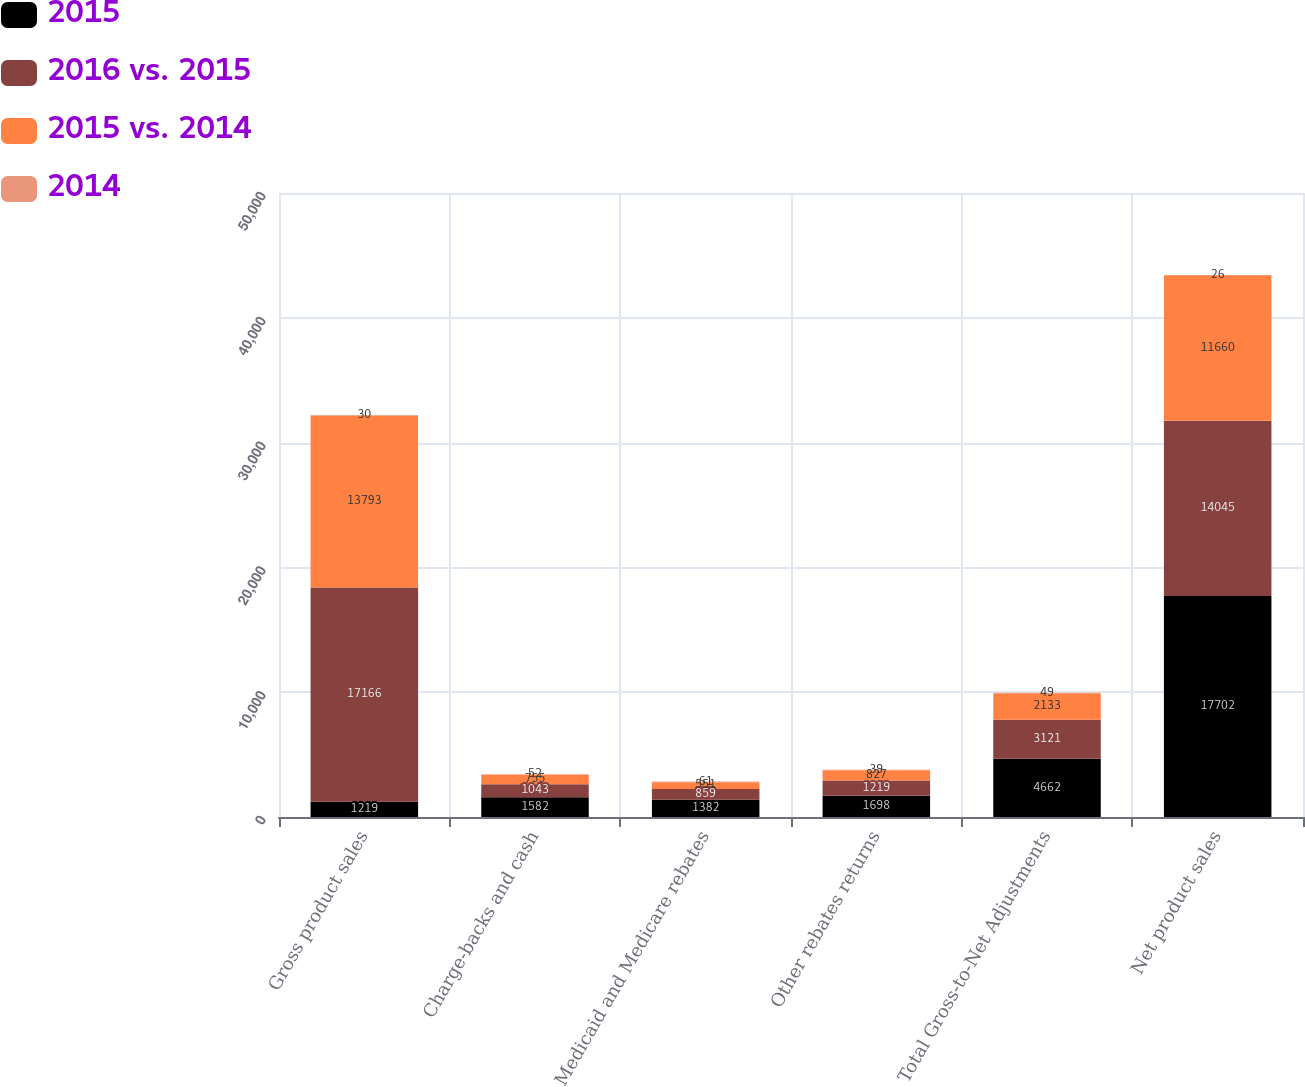<chart> <loc_0><loc_0><loc_500><loc_500><stacked_bar_chart><ecel><fcel>Gross product sales<fcel>Charge-backs and cash<fcel>Medicaid and Medicare rebates<fcel>Other rebates returns<fcel>Total Gross-to-Net Adjustments<fcel>Net product sales<nl><fcel>2015<fcel>1219<fcel>1582<fcel>1382<fcel>1698<fcel>4662<fcel>17702<nl><fcel>2016 vs. 2015<fcel>17166<fcel>1043<fcel>859<fcel>1219<fcel>3121<fcel>14045<nl><fcel>2015 vs. 2014<fcel>13793<fcel>755<fcel>551<fcel>827<fcel>2133<fcel>11660<nl><fcel>2014<fcel>30<fcel>52<fcel>61<fcel>39<fcel>49<fcel>26<nl></chart> 